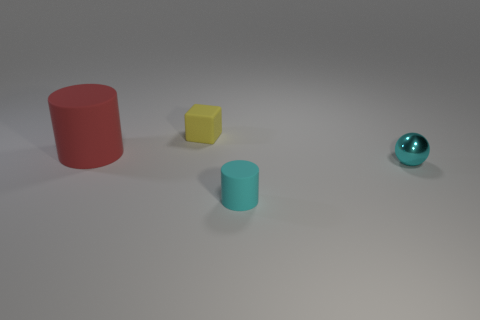Are there more small cylinders in front of the red cylinder than tiny yellow rubber cubes that are behind the small yellow rubber block?
Provide a succinct answer. Yes. Is there a matte object of the same size as the yellow matte cube?
Keep it short and to the point. Yes. What size is the matte cylinder to the left of the tiny yellow thing behind the matte object in front of the big cylinder?
Your answer should be compact. Large. What is the color of the big matte cylinder?
Provide a short and direct response. Red. Are there more small rubber objects that are on the left side of the metallic sphere than yellow things?
Provide a succinct answer. Yes. How many objects are on the right side of the small cyan rubber thing?
Your response must be concise. 1. There is another object that is the same color as the shiny object; what shape is it?
Your answer should be compact. Cylinder. Are there any yellow matte blocks left of the rubber thing that is left of the rubber object that is behind the big red cylinder?
Make the answer very short. No. Do the cyan shiny sphere and the red rubber object have the same size?
Offer a terse response. No. Is the number of tiny yellow matte things in front of the small rubber cube the same as the number of metal objects on the left side of the red thing?
Your response must be concise. Yes. 